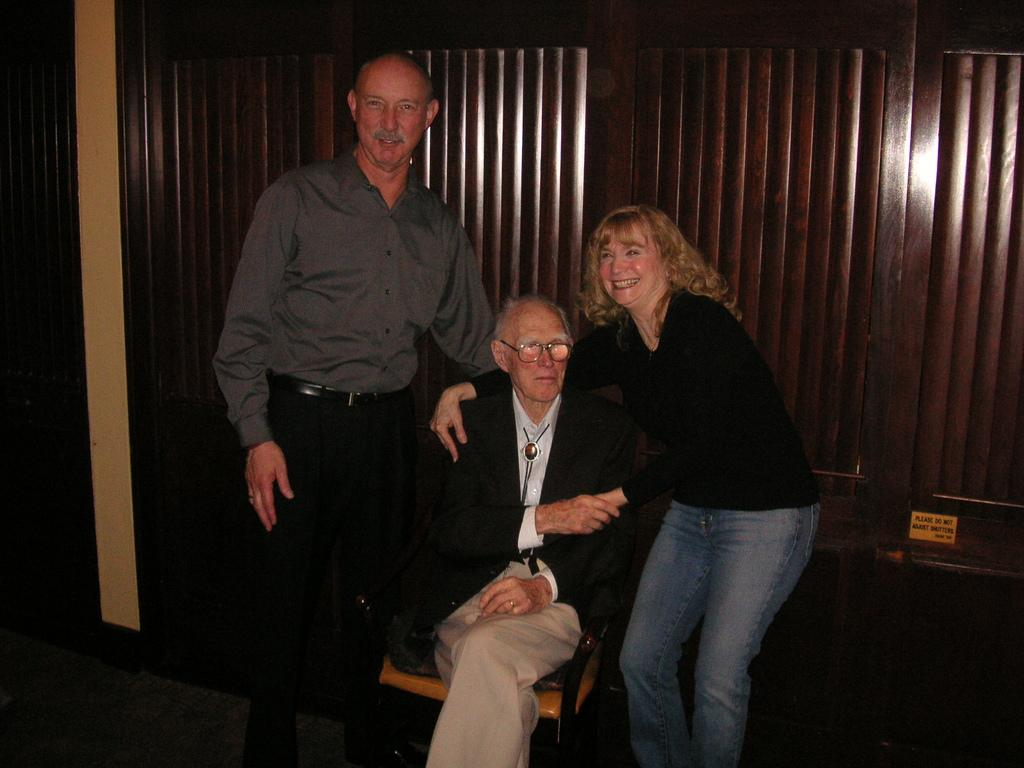How many people are present in the image? There are three people in the image. What is the position of one of the people in the image? One person is sitting on a chair. What can be seen in the background of the image? There is a wall in the background of the image. What impulse is causing the team to move forward in the image? There is no team or impulse present in the image; it features three people, one of whom is sitting on a chair. 